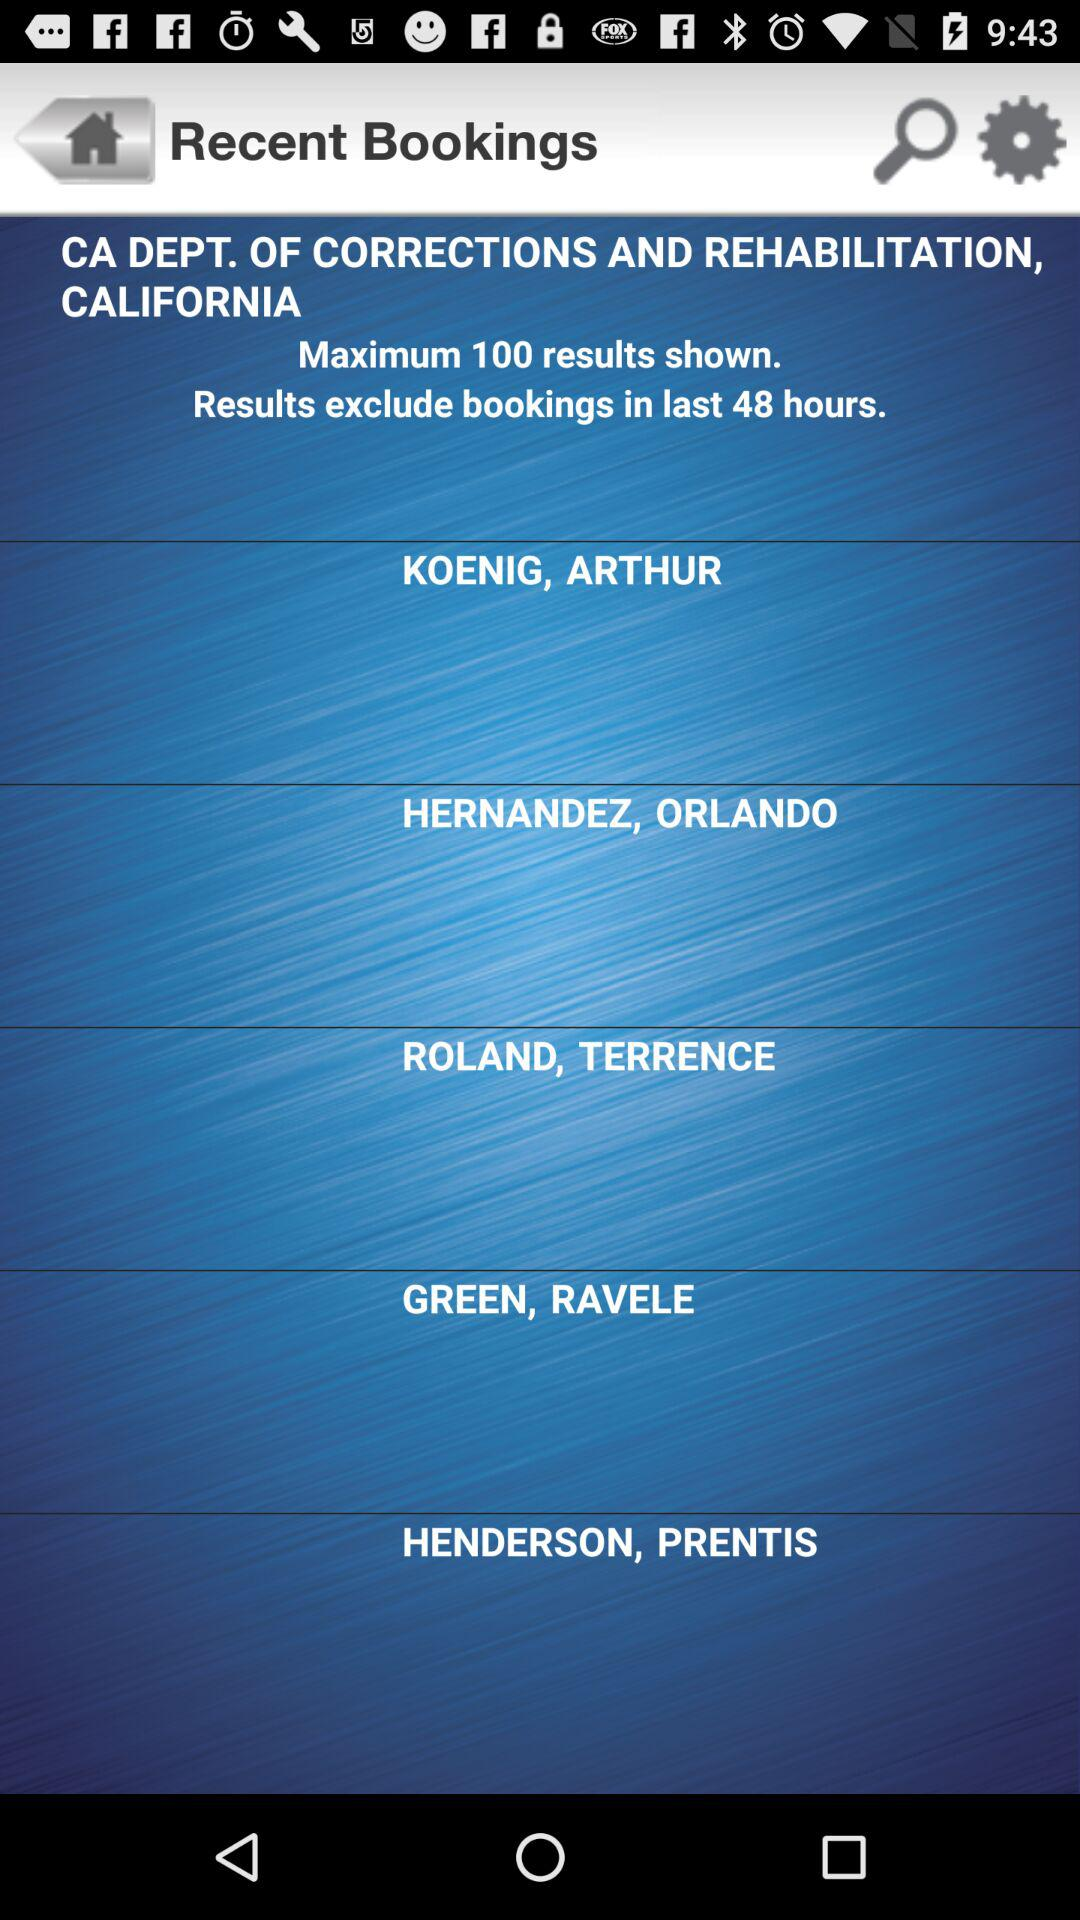How old is Prentis Henderson?
When the provided information is insufficient, respond with <no answer>. <no answer> 